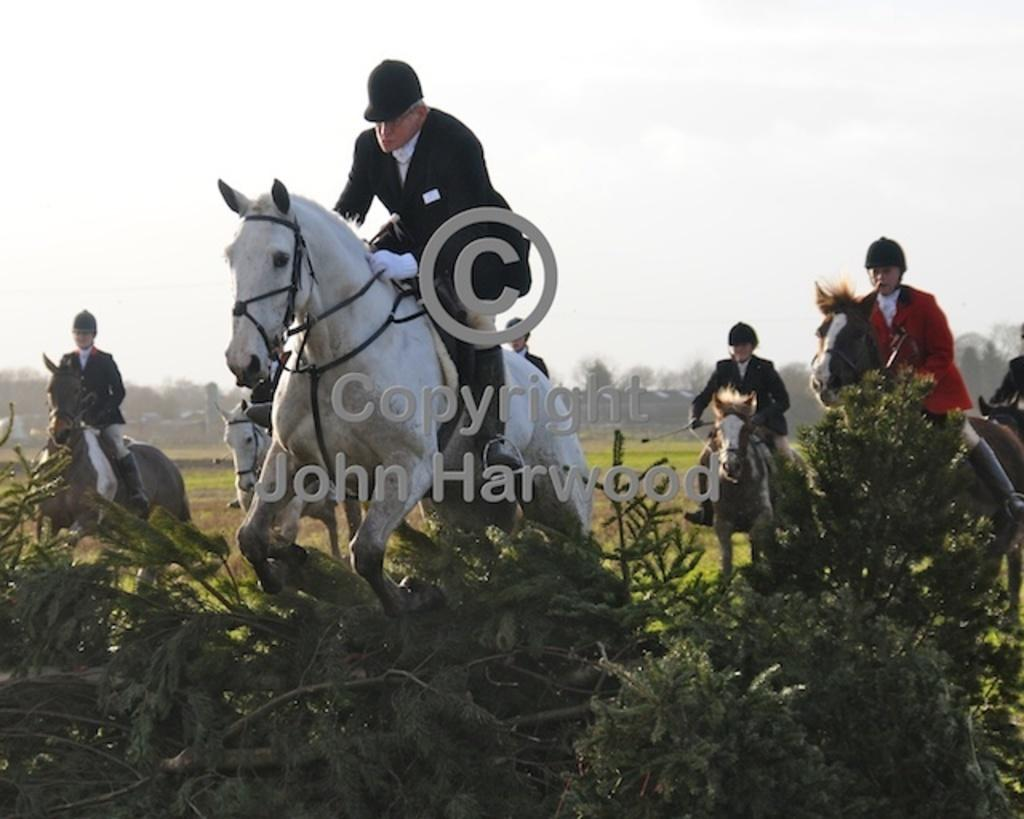What are the people in the image doing? The people in the image are riding horses. What can be seen in the background of the image? Plants and trees are visible in the background of the image. What are the people wearing on their heads? The people are wearing caps on their heads. What type of clothing are the people wearing? The people are wearing suits. Where are the dinosaurs in the image? There are no dinosaurs present in the image. What type of frame is around the image? The provided facts do not mention any frame around the image. 